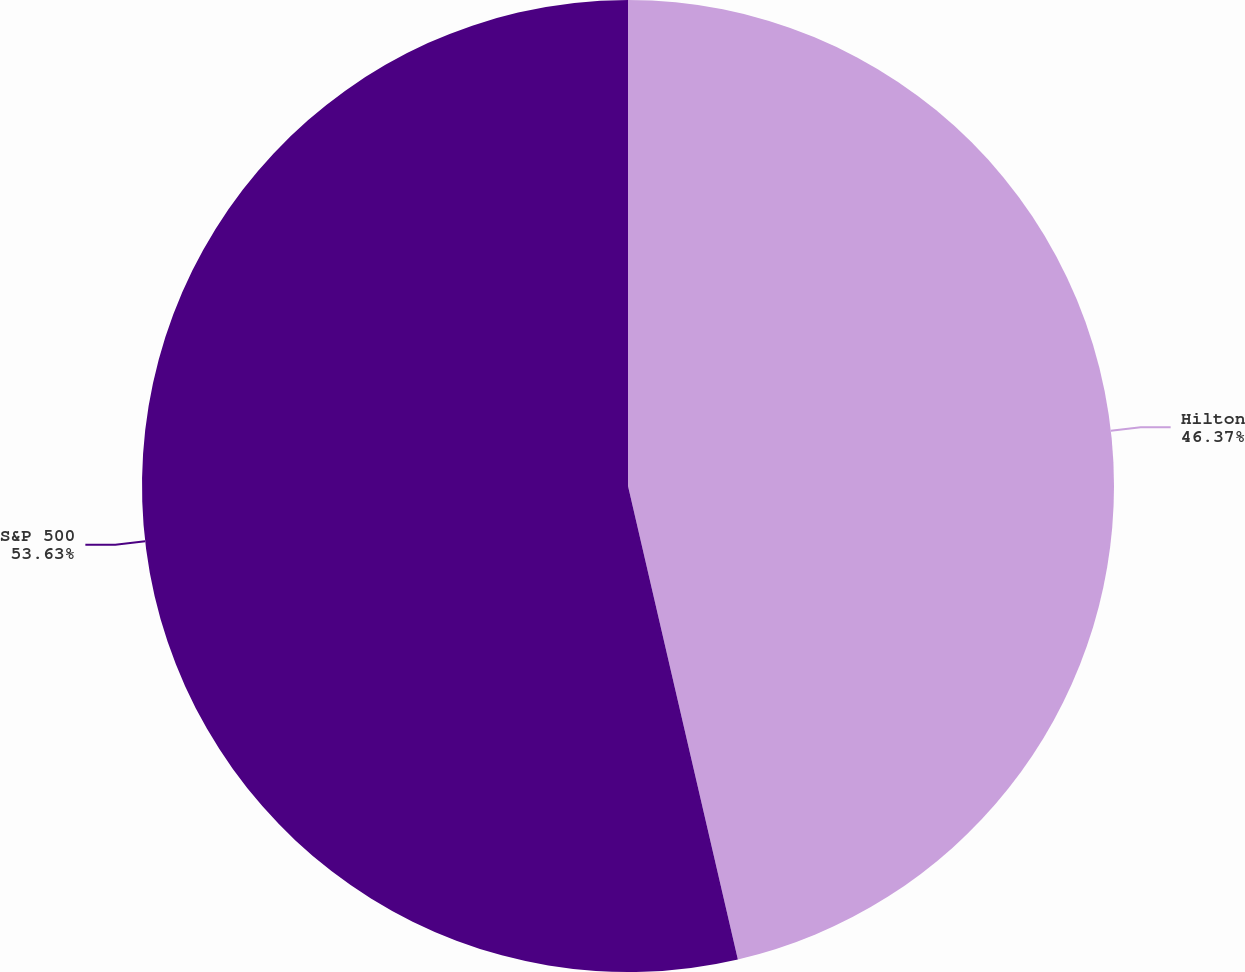<chart> <loc_0><loc_0><loc_500><loc_500><pie_chart><fcel>Hilton<fcel>S&P 500<nl><fcel>46.37%<fcel>53.63%<nl></chart> 